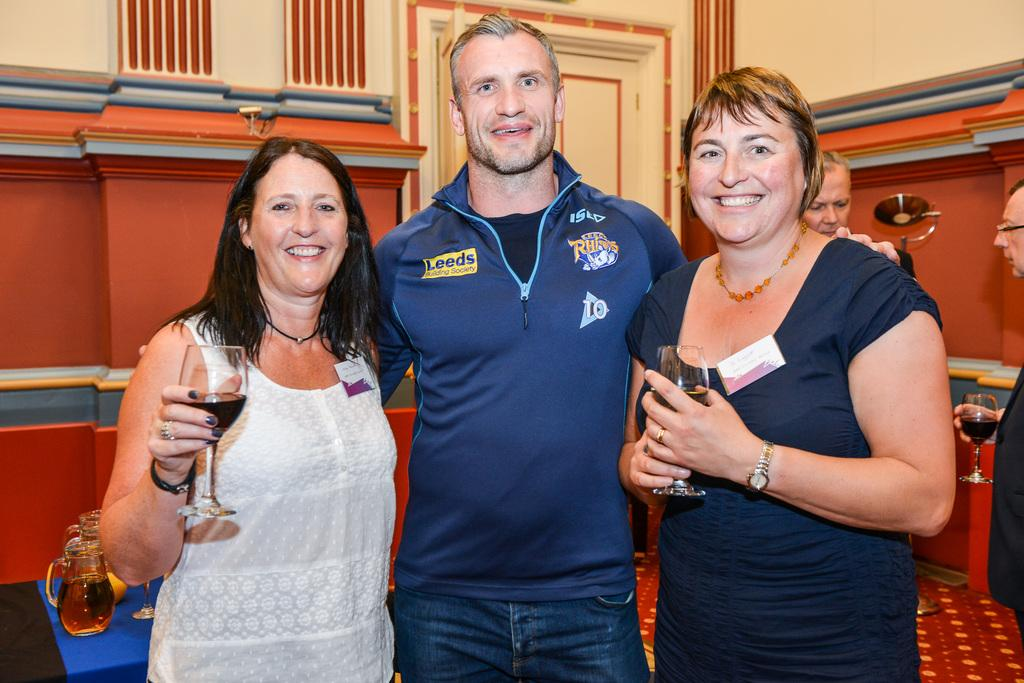How many people are standing together in the image? There are three people standing together in the image. What are the ladies holding in their hands? Two ladies are holding glasses with alcohol. What activity are the people engaged in? There are people talking to each other in a room. Can you hear the sound of the cough in the image? There is no sound or cough present in the image, as it is a still photograph. 